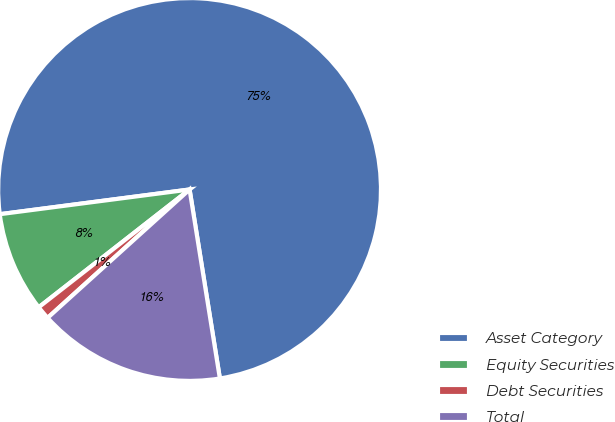Convert chart to OTSL. <chart><loc_0><loc_0><loc_500><loc_500><pie_chart><fcel>Asset Category<fcel>Equity Securities<fcel>Debt Securities<fcel>Total<nl><fcel>74.53%<fcel>8.49%<fcel>1.15%<fcel>15.83%<nl></chart> 